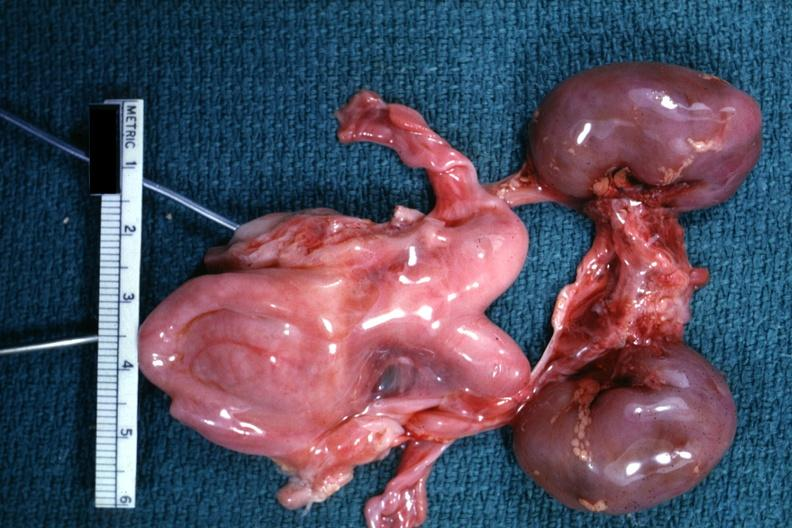s beckwith-wiedemann syndrome present?
Answer the question using a single word or phrase. No 